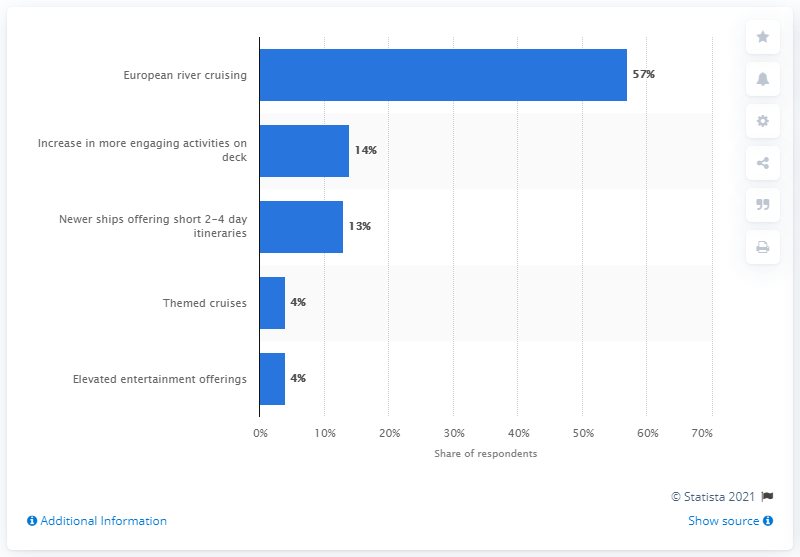Draw attention to some important aspects in this diagram. In 2014, the top cruise trend for U.S. travelers was European river cruising. 